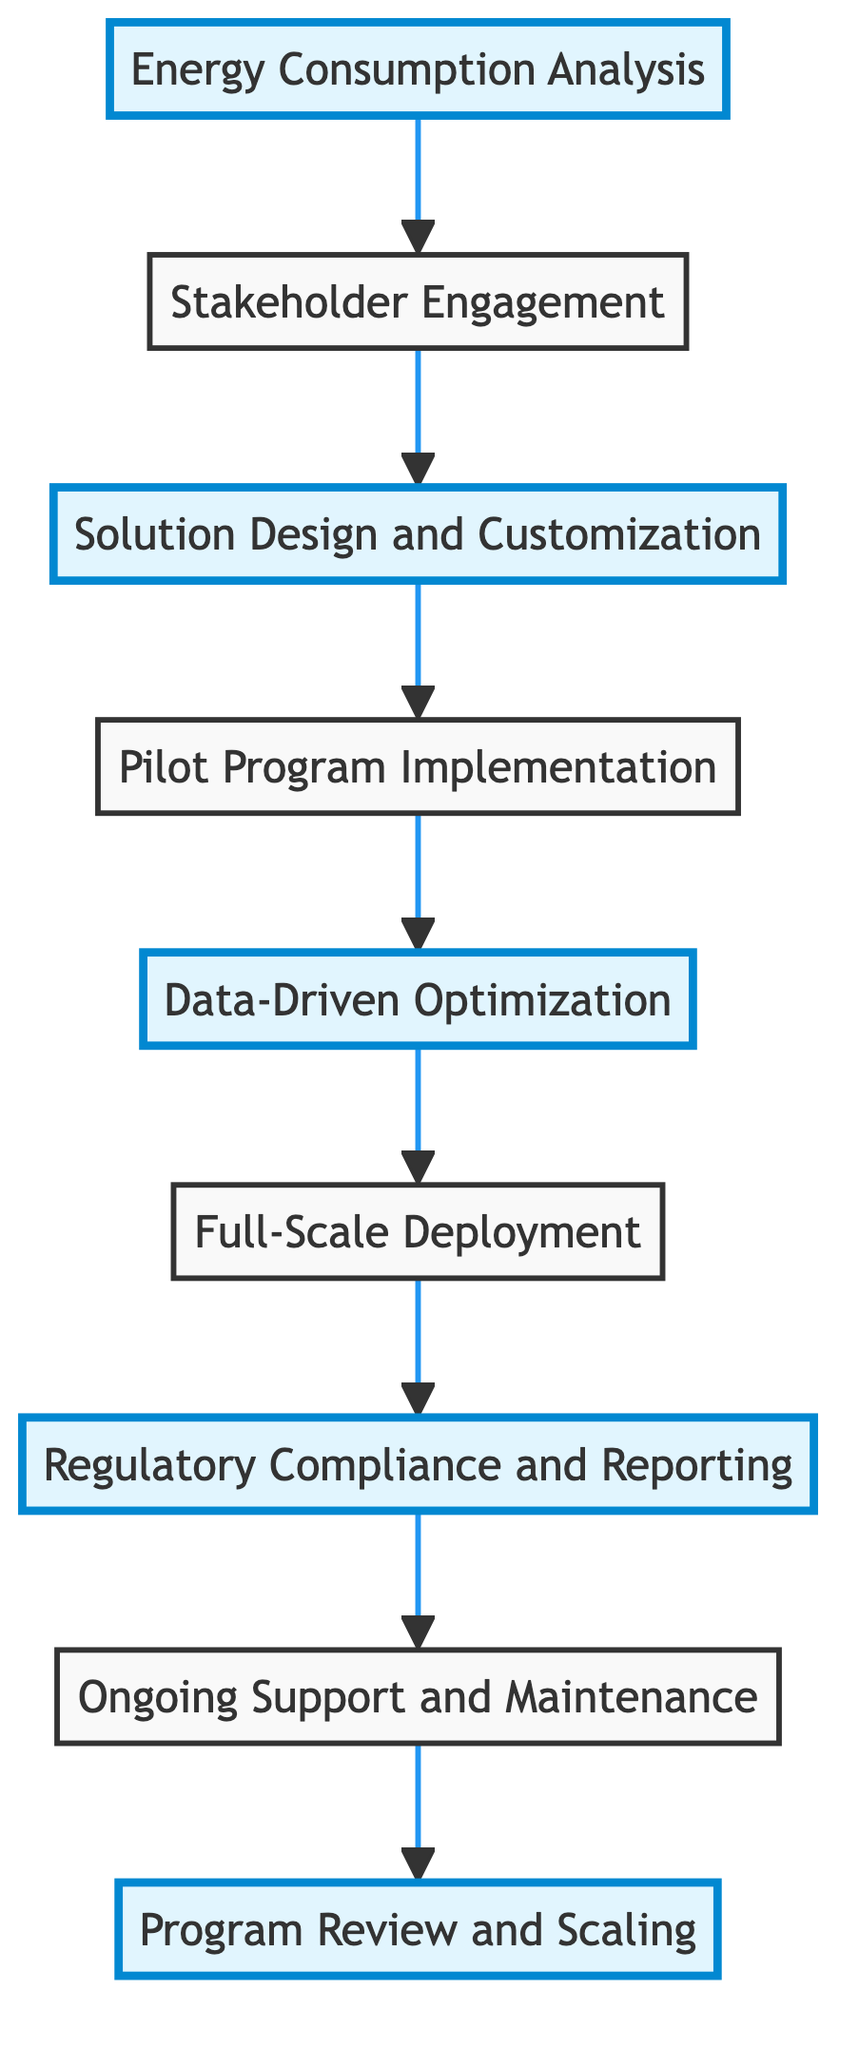What is the first step of the energy efficiency program? The diagram starts with "Energy Consumption Analysis," which is represented at the bottom of the flow chart.
Answer: Energy Consumption Analysis How many steps are there in total in this flow chart? The flow chart has a total of eight distinct steps, which are each represented by nodes connected in a sequence.
Answer: 8 Which step follows the "Pilot Program Implementation"? After "Pilot Program Implementation," the next step, according to the flow indicated in the diagram, is "Data-Driven Optimization."
Answer: Data-Driven Optimization What is the last step in the process? The last step is "Program Review and Scaling," which is positioned at the top of the flow chart, indicating it's the final action taken after all others.
Answer: Program Review and Scaling Which two steps are directly connected to "Solution Design and Customization"? The steps that are directly connected to "Solution Design and Customization" are "Stakeholder Engagement" (located below) and "Pilot Program Implementation" (located above).
Answer: Stakeholder Engagement, Pilot Program Implementation What type of support is planned for long-term sustainability? The step "Ongoing Support and Maintenance" describes the establishment of support and maintenance plans for the long-term sustainability of the solutions implemented.
Answer: Ongoing Support and Maintenance Which step emphasizes regulatory compliance? The step labeled "Regulatory Compliance and Reporting" specifically focuses on ensuring that all solutions conform to legal standards and reporting requirements.
Answer: Regulatory Compliance and Reporting What occurs after "Data-Driven Optimization"? Following "Data-Driven Optimization," the next step is "Full-Scale Deployment," indicating an expansion phase after optimization.
Answer: Full-Scale Deployment 